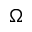Convert formula to latex. <formula><loc_0><loc_0><loc_500><loc_500>\Omega</formula> 